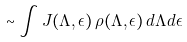Convert formula to latex. <formula><loc_0><loc_0><loc_500><loc_500>\sim \int J ( \Lambda , \epsilon ) \, \rho ( \Lambda , \epsilon ) \, d \Lambda d \epsilon</formula> 